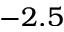Convert formula to latex. <formula><loc_0><loc_0><loc_500><loc_500>- 2 . 5</formula> 